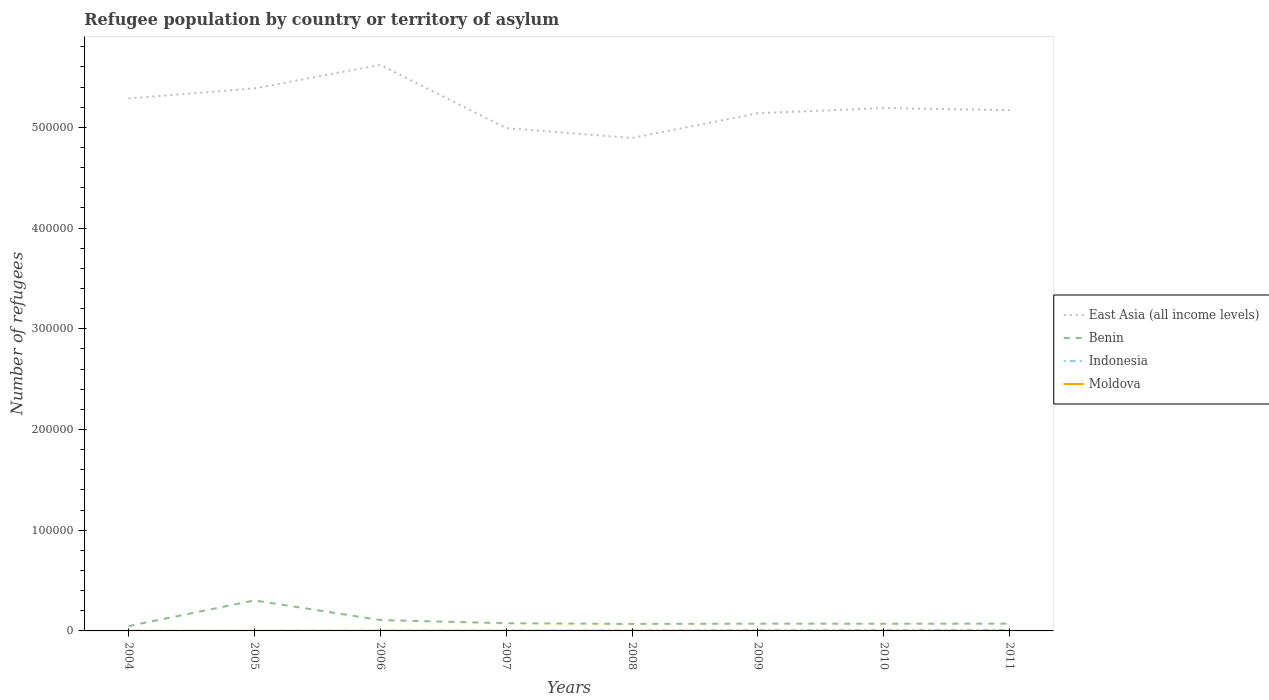Does the line corresponding to Indonesia intersect with the line corresponding to East Asia (all income levels)?
Your answer should be compact. No. Across all years, what is the maximum number of refugees in Benin?
Offer a terse response. 4802. What is the total number of refugees in Benin in the graph?
Ensure brevity in your answer.  -206. What is the difference between the highest and the second highest number of refugees in Moldova?
Give a very brief answer. 104. What is the difference between the highest and the lowest number of refugees in Moldova?
Your answer should be very brief. 6. Is the number of refugees in East Asia (all income levels) strictly greater than the number of refugees in Indonesia over the years?
Provide a short and direct response. No. How many lines are there?
Offer a terse response. 4. What is the difference between two consecutive major ticks on the Y-axis?
Offer a very short reply. 1.00e+05. Does the graph contain grids?
Offer a very short reply. No. Where does the legend appear in the graph?
Offer a terse response. Center right. How many legend labels are there?
Provide a succinct answer. 4. How are the legend labels stacked?
Keep it short and to the point. Vertical. What is the title of the graph?
Make the answer very short. Refugee population by country or territory of asylum. What is the label or title of the Y-axis?
Offer a terse response. Number of refugees. What is the Number of refugees of East Asia (all income levels) in 2004?
Your answer should be very brief. 5.29e+05. What is the Number of refugees of Benin in 2004?
Keep it short and to the point. 4802. What is the Number of refugees of Indonesia in 2004?
Offer a terse response. 169. What is the Number of refugees in Moldova in 2004?
Offer a terse response. 57. What is the Number of refugees of East Asia (all income levels) in 2005?
Your answer should be compact. 5.39e+05. What is the Number of refugees of Benin in 2005?
Ensure brevity in your answer.  3.03e+04. What is the Number of refugees of Indonesia in 2005?
Your answer should be compact. 89. What is the Number of refugees in East Asia (all income levels) in 2006?
Your answer should be compact. 5.62e+05. What is the Number of refugees of Benin in 2006?
Ensure brevity in your answer.  1.08e+04. What is the Number of refugees in Indonesia in 2006?
Your response must be concise. 301. What is the Number of refugees in Moldova in 2006?
Make the answer very short. 161. What is the Number of refugees in East Asia (all income levels) in 2007?
Your response must be concise. 4.99e+05. What is the Number of refugees in Benin in 2007?
Ensure brevity in your answer.  7621. What is the Number of refugees of Indonesia in 2007?
Keep it short and to the point. 315. What is the Number of refugees of Moldova in 2007?
Give a very brief answer. 151. What is the Number of refugees in East Asia (all income levels) in 2008?
Ensure brevity in your answer.  4.90e+05. What is the Number of refugees of Benin in 2008?
Provide a succinct answer. 6933. What is the Number of refugees of Indonesia in 2008?
Offer a very short reply. 369. What is the Number of refugees in Moldova in 2008?
Provide a short and direct response. 148. What is the Number of refugees in East Asia (all income levels) in 2009?
Provide a short and direct response. 5.14e+05. What is the Number of refugees in Benin in 2009?
Make the answer very short. 7205. What is the Number of refugees in Indonesia in 2009?
Your answer should be very brief. 798. What is the Number of refugees of Moldova in 2009?
Keep it short and to the point. 141. What is the Number of refugees in East Asia (all income levels) in 2010?
Offer a very short reply. 5.19e+05. What is the Number of refugees in Benin in 2010?
Provide a short and direct response. 7139. What is the Number of refugees of Indonesia in 2010?
Ensure brevity in your answer.  811. What is the Number of refugees of Moldova in 2010?
Your answer should be very brief. 148. What is the Number of refugees in East Asia (all income levels) in 2011?
Your answer should be compact. 5.17e+05. What is the Number of refugees of Benin in 2011?
Offer a very short reply. 7217. What is the Number of refugees of Indonesia in 2011?
Make the answer very short. 1006. What is the Number of refugees in Moldova in 2011?
Your answer should be very brief. 146. Across all years, what is the maximum Number of refugees in East Asia (all income levels)?
Your answer should be compact. 5.62e+05. Across all years, what is the maximum Number of refugees of Benin?
Your response must be concise. 3.03e+04. Across all years, what is the maximum Number of refugees in Indonesia?
Offer a terse response. 1006. Across all years, what is the maximum Number of refugees of Moldova?
Your answer should be very brief. 161. Across all years, what is the minimum Number of refugees of East Asia (all income levels)?
Offer a very short reply. 4.90e+05. Across all years, what is the minimum Number of refugees of Benin?
Make the answer very short. 4802. Across all years, what is the minimum Number of refugees of Indonesia?
Keep it short and to the point. 89. Across all years, what is the minimum Number of refugees in Moldova?
Your response must be concise. 57. What is the total Number of refugees in East Asia (all income levels) in the graph?
Your response must be concise. 4.17e+06. What is the total Number of refugees in Benin in the graph?
Give a very brief answer. 8.20e+04. What is the total Number of refugees of Indonesia in the graph?
Your answer should be very brief. 3858. What is the total Number of refugees in Moldova in the graph?
Make the answer very short. 1036. What is the difference between the Number of refugees of East Asia (all income levels) in 2004 and that in 2005?
Give a very brief answer. -9903. What is the difference between the Number of refugees in Benin in 2004 and that in 2005?
Ensure brevity in your answer.  -2.55e+04. What is the difference between the Number of refugees in Indonesia in 2004 and that in 2005?
Provide a succinct answer. 80. What is the difference between the Number of refugees of Moldova in 2004 and that in 2005?
Offer a terse response. -27. What is the difference between the Number of refugees of East Asia (all income levels) in 2004 and that in 2006?
Make the answer very short. -3.33e+04. What is the difference between the Number of refugees in Benin in 2004 and that in 2006?
Your response must be concise. -5995. What is the difference between the Number of refugees in Indonesia in 2004 and that in 2006?
Give a very brief answer. -132. What is the difference between the Number of refugees of Moldova in 2004 and that in 2006?
Offer a terse response. -104. What is the difference between the Number of refugees of East Asia (all income levels) in 2004 and that in 2007?
Keep it short and to the point. 2.95e+04. What is the difference between the Number of refugees of Benin in 2004 and that in 2007?
Give a very brief answer. -2819. What is the difference between the Number of refugees in Indonesia in 2004 and that in 2007?
Give a very brief answer. -146. What is the difference between the Number of refugees in Moldova in 2004 and that in 2007?
Your answer should be very brief. -94. What is the difference between the Number of refugees of East Asia (all income levels) in 2004 and that in 2008?
Offer a terse response. 3.92e+04. What is the difference between the Number of refugees of Benin in 2004 and that in 2008?
Your answer should be very brief. -2131. What is the difference between the Number of refugees of Indonesia in 2004 and that in 2008?
Ensure brevity in your answer.  -200. What is the difference between the Number of refugees in Moldova in 2004 and that in 2008?
Offer a very short reply. -91. What is the difference between the Number of refugees of East Asia (all income levels) in 2004 and that in 2009?
Keep it short and to the point. 1.47e+04. What is the difference between the Number of refugees in Benin in 2004 and that in 2009?
Your answer should be compact. -2403. What is the difference between the Number of refugees in Indonesia in 2004 and that in 2009?
Provide a succinct answer. -629. What is the difference between the Number of refugees in Moldova in 2004 and that in 2009?
Provide a succinct answer. -84. What is the difference between the Number of refugees in East Asia (all income levels) in 2004 and that in 2010?
Your answer should be very brief. 9552. What is the difference between the Number of refugees in Benin in 2004 and that in 2010?
Your response must be concise. -2337. What is the difference between the Number of refugees of Indonesia in 2004 and that in 2010?
Offer a very short reply. -642. What is the difference between the Number of refugees in Moldova in 2004 and that in 2010?
Provide a succinct answer. -91. What is the difference between the Number of refugees of East Asia (all income levels) in 2004 and that in 2011?
Provide a succinct answer. 1.17e+04. What is the difference between the Number of refugees of Benin in 2004 and that in 2011?
Give a very brief answer. -2415. What is the difference between the Number of refugees in Indonesia in 2004 and that in 2011?
Ensure brevity in your answer.  -837. What is the difference between the Number of refugees of Moldova in 2004 and that in 2011?
Provide a succinct answer. -89. What is the difference between the Number of refugees in East Asia (all income levels) in 2005 and that in 2006?
Provide a short and direct response. -2.34e+04. What is the difference between the Number of refugees in Benin in 2005 and that in 2006?
Your answer should be very brief. 1.95e+04. What is the difference between the Number of refugees of Indonesia in 2005 and that in 2006?
Ensure brevity in your answer.  -212. What is the difference between the Number of refugees of Moldova in 2005 and that in 2006?
Provide a succinct answer. -77. What is the difference between the Number of refugees in East Asia (all income levels) in 2005 and that in 2007?
Your answer should be compact. 3.94e+04. What is the difference between the Number of refugees in Benin in 2005 and that in 2007?
Keep it short and to the point. 2.27e+04. What is the difference between the Number of refugees of Indonesia in 2005 and that in 2007?
Your response must be concise. -226. What is the difference between the Number of refugees in Moldova in 2005 and that in 2007?
Keep it short and to the point. -67. What is the difference between the Number of refugees in East Asia (all income levels) in 2005 and that in 2008?
Your answer should be very brief. 4.92e+04. What is the difference between the Number of refugees of Benin in 2005 and that in 2008?
Your response must be concise. 2.34e+04. What is the difference between the Number of refugees in Indonesia in 2005 and that in 2008?
Your response must be concise. -280. What is the difference between the Number of refugees in Moldova in 2005 and that in 2008?
Make the answer very short. -64. What is the difference between the Number of refugees of East Asia (all income levels) in 2005 and that in 2009?
Your answer should be very brief. 2.46e+04. What is the difference between the Number of refugees of Benin in 2005 and that in 2009?
Your response must be concise. 2.31e+04. What is the difference between the Number of refugees of Indonesia in 2005 and that in 2009?
Provide a short and direct response. -709. What is the difference between the Number of refugees in Moldova in 2005 and that in 2009?
Ensure brevity in your answer.  -57. What is the difference between the Number of refugees in East Asia (all income levels) in 2005 and that in 2010?
Offer a very short reply. 1.95e+04. What is the difference between the Number of refugees of Benin in 2005 and that in 2010?
Ensure brevity in your answer.  2.32e+04. What is the difference between the Number of refugees in Indonesia in 2005 and that in 2010?
Ensure brevity in your answer.  -722. What is the difference between the Number of refugees in Moldova in 2005 and that in 2010?
Offer a terse response. -64. What is the difference between the Number of refugees in East Asia (all income levels) in 2005 and that in 2011?
Make the answer very short. 2.16e+04. What is the difference between the Number of refugees in Benin in 2005 and that in 2011?
Give a very brief answer. 2.31e+04. What is the difference between the Number of refugees of Indonesia in 2005 and that in 2011?
Ensure brevity in your answer.  -917. What is the difference between the Number of refugees of Moldova in 2005 and that in 2011?
Ensure brevity in your answer.  -62. What is the difference between the Number of refugees of East Asia (all income levels) in 2006 and that in 2007?
Provide a short and direct response. 6.28e+04. What is the difference between the Number of refugees in Benin in 2006 and that in 2007?
Make the answer very short. 3176. What is the difference between the Number of refugees in Indonesia in 2006 and that in 2007?
Provide a short and direct response. -14. What is the difference between the Number of refugees in East Asia (all income levels) in 2006 and that in 2008?
Make the answer very short. 7.26e+04. What is the difference between the Number of refugees of Benin in 2006 and that in 2008?
Make the answer very short. 3864. What is the difference between the Number of refugees in Indonesia in 2006 and that in 2008?
Ensure brevity in your answer.  -68. What is the difference between the Number of refugees in Moldova in 2006 and that in 2008?
Your answer should be compact. 13. What is the difference between the Number of refugees of East Asia (all income levels) in 2006 and that in 2009?
Offer a terse response. 4.80e+04. What is the difference between the Number of refugees in Benin in 2006 and that in 2009?
Offer a terse response. 3592. What is the difference between the Number of refugees of Indonesia in 2006 and that in 2009?
Your response must be concise. -497. What is the difference between the Number of refugees of East Asia (all income levels) in 2006 and that in 2010?
Offer a terse response. 4.29e+04. What is the difference between the Number of refugees of Benin in 2006 and that in 2010?
Ensure brevity in your answer.  3658. What is the difference between the Number of refugees of Indonesia in 2006 and that in 2010?
Your response must be concise. -510. What is the difference between the Number of refugees of East Asia (all income levels) in 2006 and that in 2011?
Your response must be concise. 4.50e+04. What is the difference between the Number of refugees of Benin in 2006 and that in 2011?
Your answer should be compact. 3580. What is the difference between the Number of refugees of Indonesia in 2006 and that in 2011?
Give a very brief answer. -705. What is the difference between the Number of refugees in Moldova in 2006 and that in 2011?
Keep it short and to the point. 15. What is the difference between the Number of refugees of East Asia (all income levels) in 2007 and that in 2008?
Ensure brevity in your answer.  9746. What is the difference between the Number of refugees of Benin in 2007 and that in 2008?
Your answer should be very brief. 688. What is the difference between the Number of refugees in Indonesia in 2007 and that in 2008?
Ensure brevity in your answer.  -54. What is the difference between the Number of refugees of East Asia (all income levels) in 2007 and that in 2009?
Offer a terse response. -1.48e+04. What is the difference between the Number of refugees in Benin in 2007 and that in 2009?
Your answer should be compact. 416. What is the difference between the Number of refugees of Indonesia in 2007 and that in 2009?
Your answer should be very brief. -483. What is the difference between the Number of refugees of Moldova in 2007 and that in 2009?
Provide a succinct answer. 10. What is the difference between the Number of refugees of East Asia (all income levels) in 2007 and that in 2010?
Make the answer very short. -2.00e+04. What is the difference between the Number of refugees in Benin in 2007 and that in 2010?
Give a very brief answer. 482. What is the difference between the Number of refugees of Indonesia in 2007 and that in 2010?
Give a very brief answer. -496. What is the difference between the Number of refugees of Moldova in 2007 and that in 2010?
Your answer should be very brief. 3. What is the difference between the Number of refugees of East Asia (all income levels) in 2007 and that in 2011?
Your answer should be very brief. -1.78e+04. What is the difference between the Number of refugees in Benin in 2007 and that in 2011?
Your answer should be compact. 404. What is the difference between the Number of refugees of Indonesia in 2007 and that in 2011?
Ensure brevity in your answer.  -691. What is the difference between the Number of refugees in Moldova in 2007 and that in 2011?
Keep it short and to the point. 5. What is the difference between the Number of refugees of East Asia (all income levels) in 2008 and that in 2009?
Give a very brief answer. -2.46e+04. What is the difference between the Number of refugees of Benin in 2008 and that in 2009?
Offer a terse response. -272. What is the difference between the Number of refugees of Indonesia in 2008 and that in 2009?
Make the answer very short. -429. What is the difference between the Number of refugees of East Asia (all income levels) in 2008 and that in 2010?
Make the answer very short. -2.97e+04. What is the difference between the Number of refugees in Benin in 2008 and that in 2010?
Ensure brevity in your answer.  -206. What is the difference between the Number of refugees of Indonesia in 2008 and that in 2010?
Provide a short and direct response. -442. What is the difference between the Number of refugees of East Asia (all income levels) in 2008 and that in 2011?
Provide a succinct answer. -2.76e+04. What is the difference between the Number of refugees in Benin in 2008 and that in 2011?
Provide a short and direct response. -284. What is the difference between the Number of refugees in Indonesia in 2008 and that in 2011?
Ensure brevity in your answer.  -637. What is the difference between the Number of refugees in East Asia (all income levels) in 2009 and that in 2010?
Your answer should be very brief. -5144. What is the difference between the Number of refugees of East Asia (all income levels) in 2009 and that in 2011?
Make the answer very short. -3021. What is the difference between the Number of refugees in Indonesia in 2009 and that in 2011?
Your response must be concise. -208. What is the difference between the Number of refugees in Moldova in 2009 and that in 2011?
Offer a very short reply. -5. What is the difference between the Number of refugees of East Asia (all income levels) in 2010 and that in 2011?
Offer a very short reply. 2123. What is the difference between the Number of refugees in Benin in 2010 and that in 2011?
Your answer should be very brief. -78. What is the difference between the Number of refugees in Indonesia in 2010 and that in 2011?
Ensure brevity in your answer.  -195. What is the difference between the Number of refugees in East Asia (all income levels) in 2004 and the Number of refugees in Benin in 2005?
Your response must be concise. 4.98e+05. What is the difference between the Number of refugees of East Asia (all income levels) in 2004 and the Number of refugees of Indonesia in 2005?
Make the answer very short. 5.29e+05. What is the difference between the Number of refugees of East Asia (all income levels) in 2004 and the Number of refugees of Moldova in 2005?
Offer a terse response. 5.29e+05. What is the difference between the Number of refugees of Benin in 2004 and the Number of refugees of Indonesia in 2005?
Your answer should be very brief. 4713. What is the difference between the Number of refugees in Benin in 2004 and the Number of refugees in Moldova in 2005?
Make the answer very short. 4718. What is the difference between the Number of refugees in Indonesia in 2004 and the Number of refugees in Moldova in 2005?
Keep it short and to the point. 85. What is the difference between the Number of refugees of East Asia (all income levels) in 2004 and the Number of refugees of Benin in 2006?
Ensure brevity in your answer.  5.18e+05. What is the difference between the Number of refugees of East Asia (all income levels) in 2004 and the Number of refugees of Indonesia in 2006?
Your response must be concise. 5.28e+05. What is the difference between the Number of refugees of East Asia (all income levels) in 2004 and the Number of refugees of Moldova in 2006?
Keep it short and to the point. 5.29e+05. What is the difference between the Number of refugees of Benin in 2004 and the Number of refugees of Indonesia in 2006?
Your answer should be compact. 4501. What is the difference between the Number of refugees in Benin in 2004 and the Number of refugees in Moldova in 2006?
Provide a succinct answer. 4641. What is the difference between the Number of refugees in East Asia (all income levels) in 2004 and the Number of refugees in Benin in 2007?
Give a very brief answer. 5.21e+05. What is the difference between the Number of refugees in East Asia (all income levels) in 2004 and the Number of refugees in Indonesia in 2007?
Ensure brevity in your answer.  5.28e+05. What is the difference between the Number of refugees in East Asia (all income levels) in 2004 and the Number of refugees in Moldova in 2007?
Your response must be concise. 5.29e+05. What is the difference between the Number of refugees in Benin in 2004 and the Number of refugees in Indonesia in 2007?
Provide a short and direct response. 4487. What is the difference between the Number of refugees in Benin in 2004 and the Number of refugees in Moldova in 2007?
Ensure brevity in your answer.  4651. What is the difference between the Number of refugees in East Asia (all income levels) in 2004 and the Number of refugees in Benin in 2008?
Give a very brief answer. 5.22e+05. What is the difference between the Number of refugees of East Asia (all income levels) in 2004 and the Number of refugees of Indonesia in 2008?
Provide a succinct answer. 5.28e+05. What is the difference between the Number of refugees of East Asia (all income levels) in 2004 and the Number of refugees of Moldova in 2008?
Offer a terse response. 5.29e+05. What is the difference between the Number of refugees of Benin in 2004 and the Number of refugees of Indonesia in 2008?
Your answer should be compact. 4433. What is the difference between the Number of refugees of Benin in 2004 and the Number of refugees of Moldova in 2008?
Provide a short and direct response. 4654. What is the difference between the Number of refugees in Indonesia in 2004 and the Number of refugees in Moldova in 2008?
Offer a terse response. 21. What is the difference between the Number of refugees in East Asia (all income levels) in 2004 and the Number of refugees in Benin in 2009?
Your answer should be very brief. 5.22e+05. What is the difference between the Number of refugees of East Asia (all income levels) in 2004 and the Number of refugees of Indonesia in 2009?
Offer a terse response. 5.28e+05. What is the difference between the Number of refugees in East Asia (all income levels) in 2004 and the Number of refugees in Moldova in 2009?
Keep it short and to the point. 5.29e+05. What is the difference between the Number of refugees in Benin in 2004 and the Number of refugees in Indonesia in 2009?
Your answer should be compact. 4004. What is the difference between the Number of refugees of Benin in 2004 and the Number of refugees of Moldova in 2009?
Provide a succinct answer. 4661. What is the difference between the Number of refugees of East Asia (all income levels) in 2004 and the Number of refugees of Benin in 2010?
Offer a very short reply. 5.22e+05. What is the difference between the Number of refugees in East Asia (all income levels) in 2004 and the Number of refugees in Indonesia in 2010?
Give a very brief answer. 5.28e+05. What is the difference between the Number of refugees of East Asia (all income levels) in 2004 and the Number of refugees of Moldova in 2010?
Give a very brief answer. 5.29e+05. What is the difference between the Number of refugees in Benin in 2004 and the Number of refugees in Indonesia in 2010?
Offer a very short reply. 3991. What is the difference between the Number of refugees of Benin in 2004 and the Number of refugees of Moldova in 2010?
Offer a very short reply. 4654. What is the difference between the Number of refugees of Indonesia in 2004 and the Number of refugees of Moldova in 2010?
Make the answer very short. 21. What is the difference between the Number of refugees in East Asia (all income levels) in 2004 and the Number of refugees in Benin in 2011?
Your answer should be very brief. 5.22e+05. What is the difference between the Number of refugees in East Asia (all income levels) in 2004 and the Number of refugees in Indonesia in 2011?
Provide a succinct answer. 5.28e+05. What is the difference between the Number of refugees in East Asia (all income levels) in 2004 and the Number of refugees in Moldova in 2011?
Keep it short and to the point. 5.29e+05. What is the difference between the Number of refugees in Benin in 2004 and the Number of refugees in Indonesia in 2011?
Your answer should be compact. 3796. What is the difference between the Number of refugees in Benin in 2004 and the Number of refugees in Moldova in 2011?
Keep it short and to the point. 4656. What is the difference between the Number of refugees in East Asia (all income levels) in 2005 and the Number of refugees in Benin in 2006?
Provide a short and direct response. 5.28e+05. What is the difference between the Number of refugees of East Asia (all income levels) in 2005 and the Number of refugees of Indonesia in 2006?
Keep it short and to the point. 5.38e+05. What is the difference between the Number of refugees of East Asia (all income levels) in 2005 and the Number of refugees of Moldova in 2006?
Provide a succinct answer. 5.39e+05. What is the difference between the Number of refugees in Benin in 2005 and the Number of refugees in Indonesia in 2006?
Offer a terse response. 3.00e+04. What is the difference between the Number of refugees of Benin in 2005 and the Number of refugees of Moldova in 2006?
Keep it short and to the point. 3.01e+04. What is the difference between the Number of refugees of Indonesia in 2005 and the Number of refugees of Moldova in 2006?
Offer a very short reply. -72. What is the difference between the Number of refugees of East Asia (all income levels) in 2005 and the Number of refugees of Benin in 2007?
Offer a very short reply. 5.31e+05. What is the difference between the Number of refugees of East Asia (all income levels) in 2005 and the Number of refugees of Indonesia in 2007?
Offer a very short reply. 5.38e+05. What is the difference between the Number of refugees of East Asia (all income levels) in 2005 and the Number of refugees of Moldova in 2007?
Ensure brevity in your answer.  5.39e+05. What is the difference between the Number of refugees in Benin in 2005 and the Number of refugees in Indonesia in 2007?
Your response must be concise. 3.00e+04. What is the difference between the Number of refugees of Benin in 2005 and the Number of refugees of Moldova in 2007?
Provide a short and direct response. 3.01e+04. What is the difference between the Number of refugees of Indonesia in 2005 and the Number of refugees of Moldova in 2007?
Provide a succinct answer. -62. What is the difference between the Number of refugees in East Asia (all income levels) in 2005 and the Number of refugees in Benin in 2008?
Provide a short and direct response. 5.32e+05. What is the difference between the Number of refugees in East Asia (all income levels) in 2005 and the Number of refugees in Indonesia in 2008?
Provide a succinct answer. 5.38e+05. What is the difference between the Number of refugees in East Asia (all income levels) in 2005 and the Number of refugees in Moldova in 2008?
Your answer should be very brief. 5.39e+05. What is the difference between the Number of refugees in Benin in 2005 and the Number of refugees in Indonesia in 2008?
Your answer should be very brief. 2.99e+04. What is the difference between the Number of refugees of Benin in 2005 and the Number of refugees of Moldova in 2008?
Your response must be concise. 3.01e+04. What is the difference between the Number of refugees of Indonesia in 2005 and the Number of refugees of Moldova in 2008?
Offer a terse response. -59. What is the difference between the Number of refugees in East Asia (all income levels) in 2005 and the Number of refugees in Benin in 2009?
Give a very brief answer. 5.31e+05. What is the difference between the Number of refugees of East Asia (all income levels) in 2005 and the Number of refugees of Indonesia in 2009?
Provide a short and direct response. 5.38e+05. What is the difference between the Number of refugees in East Asia (all income levels) in 2005 and the Number of refugees in Moldova in 2009?
Your answer should be compact. 5.39e+05. What is the difference between the Number of refugees in Benin in 2005 and the Number of refugees in Indonesia in 2009?
Your answer should be very brief. 2.95e+04. What is the difference between the Number of refugees in Benin in 2005 and the Number of refugees in Moldova in 2009?
Make the answer very short. 3.02e+04. What is the difference between the Number of refugees in Indonesia in 2005 and the Number of refugees in Moldova in 2009?
Keep it short and to the point. -52. What is the difference between the Number of refugees of East Asia (all income levels) in 2005 and the Number of refugees of Benin in 2010?
Keep it short and to the point. 5.32e+05. What is the difference between the Number of refugees of East Asia (all income levels) in 2005 and the Number of refugees of Indonesia in 2010?
Offer a very short reply. 5.38e+05. What is the difference between the Number of refugees in East Asia (all income levels) in 2005 and the Number of refugees in Moldova in 2010?
Your answer should be very brief. 5.39e+05. What is the difference between the Number of refugees in Benin in 2005 and the Number of refugees in Indonesia in 2010?
Keep it short and to the point. 2.95e+04. What is the difference between the Number of refugees in Benin in 2005 and the Number of refugees in Moldova in 2010?
Your response must be concise. 3.01e+04. What is the difference between the Number of refugees of Indonesia in 2005 and the Number of refugees of Moldova in 2010?
Keep it short and to the point. -59. What is the difference between the Number of refugees of East Asia (all income levels) in 2005 and the Number of refugees of Benin in 2011?
Provide a short and direct response. 5.31e+05. What is the difference between the Number of refugees in East Asia (all income levels) in 2005 and the Number of refugees in Indonesia in 2011?
Provide a succinct answer. 5.38e+05. What is the difference between the Number of refugees in East Asia (all income levels) in 2005 and the Number of refugees in Moldova in 2011?
Your response must be concise. 5.39e+05. What is the difference between the Number of refugees in Benin in 2005 and the Number of refugees in Indonesia in 2011?
Provide a short and direct response. 2.93e+04. What is the difference between the Number of refugees of Benin in 2005 and the Number of refugees of Moldova in 2011?
Your response must be concise. 3.01e+04. What is the difference between the Number of refugees in Indonesia in 2005 and the Number of refugees in Moldova in 2011?
Offer a terse response. -57. What is the difference between the Number of refugees in East Asia (all income levels) in 2006 and the Number of refugees in Benin in 2007?
Your answer should be compact. 5.54e+05. What is the difference between the Number of refugees of East Asia (all income levels) in 2006 and the Number of refugees of Indonesia in 2007?
Make the answer very short. 5.62e+05. What is the difference between the Number of refugees of East Asia (all income levels) in 2006 and the Number of refugees of Moldova in 2007?
Ensure brevity in your answer.  5.62e+05. What is the difference between the Number of refugees in Benin in 2006 and the Number of refugees in Indonesia in 2007?
Provide a succinct answer. 1.05e+04. What is the difference between the Number of refugees of Benin in 2006 and the Number of refugees of Moldova in 2007?
Keep it short and to the point. 1.06e+04. What is the difference between the Number of refugees in Indonesia in 2006 and the Number of refugees in Moldova in 2007?
Make the answer very short. 150. What is the difference between the Number of refugees of East Asia (all income levels) in 2006 and the Number of refugees of Benin in 2008?
Provide a short and direct response. 5.55e+05. What is the difference between the Number of refugees in East Asia (all income levels) in 2006 and the Number of refugees in Indonesia in 2008?
Provide a short and direct response. 5.62e+05. What is the difference between the Number of refugees of East Asia (all income levels) in 2006 and the Number of refugees of Moldova in 2008?
Keep it short and to the point. 5.62e+05. What is the difference between the Number of refugees of Benin in 2006 and the Number of refugees of Indonesia in 2008?
Make the answer very short. 1.04e+04. What is the difference between the Number of refugees of Benin in 2006 and the Number of refugees of Moldova in 2008?
Keep it short and to the point. 1.06e+04. What is the difference between the Number of refugees of Indonesia in 2006 and the Number of refugees of Moldova in 2008?
Your answer should be very brief. 153. What is the difference between the Number of refugees in East Asia (all income levels) in 2006 and the Number of refugees in Benin in 2009?
Your response must be concise. 5.55e+05. What is the difference between the Number of refugees in East Asia (all income levels) in 2006 and the Number of refugees in Indonesia in 2009?
Offer a terse response. 5.61e+05. What is the difference between the Number of refugees in East Asia (all income levels) in 2006 and the Number of refugees in Moldova in 2009?
Keep it short and to the point. 5.62e+05. What is the difference between the Number of refugees in Benin in 2006 and the Number of refugees in Indonesia in 2009?
Your answer should be compact. 9999. What is the difference between the Number of refugees in Benin in 2006 and the Number of refugees in Moldova in 2009?
Give a very brief answer. 1.07e+04. What is the difference between the Number of refugees in Indonesia in 2006 and the Number of refugees in Moldova in 2009?
Provide a succinct answer. 160. What is the difference between the Number of refugees in East Asia (all income levels) in 2006 and the Number of refugees in Benin in 2010?
Give a very brief answer. 5.55e+05. What is the difference between the Number of refugees in East Asia (all income levels) in 2006 and the Number of refugees in Indonesia in 2010?
Provide a short and direct response. 5.61e+05. What is the difference between the Number of refugees of East Asia (all income levels) in 2006 and the Number of refugees of Moldova in 2010?
Your answer should be very brief. 5.62e+05. What is the difference between the Number of refugees in Benin in 2006 and the Number of refugees in Indonesia in 2010?
Make the answer very short. 9986. What is the difference between the Number of refugees in Benin in 2006 and the Number of refugees in Moldova in 2010?
Provide a succinct answer. 1.06e+04. What is the difference between the Number of refugees in Indonesia in 2006 and the Number of refugees in Moldova in 2010?
Keep it short and to the point. 153. What is the difference between the Number of refugees of East Asia (all income levels) in 2006 and the Number of refugees of Benin in 2011?
Give a very brief answer. 5.55e+05. What is the difference between the Number of refugees of East Asia (all income levels) in 2006 and the Number of refugees of Indonesia in 2011?
Offer a terse response. 5.61e+05. What is the difference between the Number of refugees in East Asia (all income levels) in 2006 and the Number of refugees in Moldova in 2011?
Keep it short and to the point. 5.62e+05. What is the difference between the Number of refugees of Benin in 2006 and the Number of refugees of Indonesia in 2011?
Offer a very short reply. 9791. What is the difference between the Number of refugees in Benin in 2006 and the Number of refugees in Moldova in 2011?
Provide a short and direct response. 1.07e+04. What is the difference between the Number of refugees of Indonesia in 2006 and the Number of refugees of Moldova in 2011?
Keep it short and to the point. 155. What is the difference between the Number of refugees in East Asia (all income levels) in 2007 and the Number of refugees in Benin in 2008?
Make the answer very short. 4.92e+05. What is the difference between the Number of refugees in East Asia (all income levels) in 2007 and the Number of refugees in Indonesia in 2008?
Ensure brevity in your answer.  4.99e+05. What is the difference between the Number of refugees of East Asia (all income levels) in 2007 and the Number of refugees of Moldova in 2008?
Your answer should be compact. 4.99e+05. What is the difference between the Number of refugees of Benin in 2007 and the Number of refugees of Indonesia in 2008?
Give a very brief answer. 7252. What is the difference between the Number of refugees in Benin in 2007 and the Number of refugees in Moldova in 2008?
Your answer should be compact. 7473. What is the difference between the Number of refugees in Indonesia in 2007 and the Number of refugees in Moldova in 2008?
Keep it short and to the point. 167. What is the difference between the Number of refugees of East Asia (all income levels) in 2007 and the Number of refugees of Benin in 2009?
Offer a terse response. 4.92e+05. What is the difference between the Number of refugees in East Asia (all income levels) in 2007 and the Number of refugees in Indonesia in 2009?
Keep it short and to the point. 4.98e+05. What is the difference between the Number of refugees of East Asia (all income levels) in 2007 and the Number of refugees of Moldova in 2009?
Make the answer very short. 4.99e+05. What is the difference between the Number of refugees in Benin in 2007 and the Number of refugees in Indonesia in 2009?
Your answer should be very brief. 6823. What is the difference between the Number of refugees of Benin in 2007 and the Number of refugees of Moldova in 2009?
Your response must be concise. 7480. What is the difference between the Number of refugees in Indonesia in 2007 and the Number of refugees in Moldova in 2009?
Provide a succinct answer. 174. What is the difference between the Number of refugees in East Asia (all income levels) in 2007 and the Number of refugees in Benin in 2010?
Your answer should be very brief. 4.92e+05. What is the difference between the Number of refugees in East Asia (all income levels) in 2007 and the Number of refugees in Indonesia in 2010?
Offer a very short reply. 4.98e+05. What is the difference between the Number of refugees of East Asia (all income levels) in 2007 and the Number of refugees of Moldova in 2010?
Ensure brevity in your answer.  4.99e+05. What is the difference between the Number of refugees in Benin in 2007 and the Number of refugees in Indonesia in 2010?
Keep it short and to the point. 6810. What is the difference between the Number of refugees of Benin in 2007 and the Number of refugees of Moldova in 2010?
Keep it short and to the point. 7473. What is the difference between the Number of refugees of Indonesia in 2007 and the Number of refugees of Moldova in 2010?
Your answer should be compact. 167. What is the difference between the Number of refugees in East Asia (all income levels) in 2007 and the Number of refugees in Benin in 2011?
Offer a very short reply. 4.92e+05. What is the difference between the Number of refugees of East Asia (all income levels) in 2007 and the Number of refugees of Indonesia in 2011?
Ensure brevity in your answer.  4.98e+05. What is the difference between the Number of refugees in East Asia (all income levels) in 2007 and the Number of refugees in Moldova in 2011?
Provide a short and direct response. 4.99e+05. What is the difference between the Number of refugees of Benin in 2007 and the Number of refugees of Indonesia in 2011?
Ensure brevity in your answer.  6615. What is the difference between the Number of refugees of Benin in 2007 and the Number of refugees of Moldova in 2011?
Ensure brevity in your answer.  7475. What is the difference between the Number of refugees in Indonesia in 2007 and the Number of refugees in Moldova in 2011?
Offer a very short reply. 169. What is the difference between the Number of refugees in East Asia (all income levels) in 2008 and the Number of refugees in Benin in 2009?
Keep it short and to the point. 4.82e+05. What is the difference between the Number of refugees of East Asia (all income levels) in 2008 and the Number of refugees of Indonesia in 2009?
Keep it short and to the point. 4.89e+05. What is the difference between the Number of refugees in East Asia (all income levels) in 2008 and the Number of refugees in Moldova in 2009?
Your response must be concise. 4.89e+05. What is the difference between the Number of refugees in Benin in 2008 and the Number of refugees in Indonesia in 2009?
Offer a very short reply. 6135. What is the difference between the Number of refugees in Benin in 2008 and the Number of refugees in Moldova in 2009?
Your response must be concise. 6792. What is the difference between the Number of refugees in Indonesia in 2008 and the Number of refugees in Moldova in 2009?
Provide a succinct answer. 228. What is the difference between the Number of refugees of East Asia (all income levels) in 2008 and the Number of refugees of Benin in 2010?
Provide a short and direct response. 4.82e+05. What is the difference between the Number of refugees of East Asia (all income levels) in 2008 and the Number of refugees of Indonesia in 2010?
Give a very brief answer. 4.89e+05. What is the difference between the Number of refugees of East Asia (all income levels) in 2008 and the Number of refugees of Moldova in 2010?
Your answer should be very brief. 4.89e+05. What is the difference between the Number of refugees in Benin in 2008 and the Number of refugees in Indonesia in 2010?
Offer a terse response. 6122. What is the difference between the Number of refugees in Benin in 2008 and the Number of refugees in Moldova in 2010?
Your answer should be very brief. 6785. What is the difference between the Number of refugees in Indonesia in 2008 and the Number of refugees in Moldova in 2010?
Your answer should be very brief. 221. What is the difference between the Number of refugees of East Asia (all income levels) in 2008 and the Number of refugees of Benin in 2011?
Your answer should be compact. 4.82e+05. What is the difference between the Number of refugees in East Asia (all income levels) in 2008 and the Number of refugees in Indonesia in 2011?
Provide a succinct answer. 4.89e+05. What is the difference between the Number of refugees of East Asia (all income levels) in 2008 and the Number of refugees of Moldova in 2011?
Your answer should be compact. 4.89e+05. What is the difference between the Number of refugees of Benin in 2008 and the Number of refugees of Indonesia in 2011?
Offer a terse response. 5927. What is the difference between the Number of refugees in Benin in 2008 and the Number of refugees in Moldova in 2011?
Offer a very short reply. 6787. What is the difference between the Number of refugees of Indonesia in 2008 and the Number of refugees of Moldova in 2011?
Your answer should be compact. 223. What is the difference between the Number of refugees of East Asia (all income levels) in 2009 and the Number of refugees of Benin in 2010?
Your answer should be very brief. 5.07e+05. What is the difference between the Number of refugees of East Asia (all income levels) in 2009 and the Number of refugees of Indonesia in 2010?
Your answer should be compact. 5.13e+05. What is the difference between the Number of refugees in East Asia (all income levels) in 2009 and the Number of refugees in Moldova in 2010?
Give a very brief answer. 5.14e+05. What is the difference between the Number of refugees in Benin in 2009 and the Number of refugees in Indonesia in 2010?
Offer a terse response. 6394. What is the difference between the Number of refugees of Benin in 2009 and the Number of refugees of Moldova in 2010?
Offer a very short reply. 7057. What is the difference between the Number of refugees in Indonesia in 2009 and the Number of refugees in Moldova in 2010?
Ensure brevity in your answer.  650. What is the difference between the Number of refugees in East Asia (all income levels) in 2009 and the Number of refugees in Benin in 2011?
Ensure brevity in your answer.  5.07e+05. What is the difference between the Number of refugees in East Asia (all income levels) in 2009 and the Number of refugees in Indonesia in 2011?
Give a very brief answer. 5.13e+05. What is the difference between the Number of refugees in East Asia (all income levels) in 2009 and the Number of refugees in Moldova in 2011?
Provide a short and direct response. 5.14e+05. What is the difference between the Number of refugees of Benin in 2009 and the Number of refugees of Indonesia in 2011?
Provide a succinct answer. 6199. What is the difference between the Number of refugees of Benin in 2009 and the Number of refugees of Moldova in 2011?
Ensure brevity in your answer.  7059. What is the difference between the Number of refugees of Indonesia in 2009 and the Number of refugees of Moldova in 2011?
Your answer should be compact. 652. What is the difference between the Number of refugees in East Asia (all income levels) in 2010 and the Number of refugees in Benin in 2011?
Keep it short and to the point. 5.12e+05. What is the difference between the Number of refugees of East Asia (all income levels) in 2010 and the Number of refugees of Indonesia in 2011?
Your answer should be compact. 5.18e+05. What is the difference between the Number of refugees in East Asia (all income levels) in 2010 and the Number of refugees in Moldova in 2011?
Your answer should be compact. 5.19e+05. What is the difference between the Number of refugees of Benin in 2010 and the Number of refugees of Indonesia in 2011?
Make the answer very short. 6133. What is the difference between the Number of refugees of Benin in 2010 and the Number of refugees of Moldova in 2011?
Your answer should be very brief. 6993. What is the difference between the Number of refugees of Indonesia in 2010 and the Number of refugees of Moldova in 2011?
Offer a terse response. 665. What is the average Number of refugees of East Asia (all income levels) per year?
Keep it short and to the point. 5.21e+05. What is the average Number of refugees of Benin per year?
Your answer should be compact. 1.03e+04. What is the average Number of refugees in Indonesia per year?
Ensure brevity in your answer.  482.25. What is the average Number of refugees in Moldova per year?
Provide a succinct answer. 129.5. In the year 2004, what is the difference between the Number of refugees of East Asia (all income levels) and Number of refugees of Benin?
Provide a short and direct response. 5.24e+05. In the year 2004, what is the difference between the Number of refugees of East Asia (all income levels) and Number of refugees of Indonesia?
Your answer should be very brief. 5.29e+05. In the year 2004, what is the difference between the Number of refugees in East Asia (all income levels) and Number of refugees in Moldova?
Make the answer very short. 5.29e+05. In the year 2004, what is the difference between the Number of refugees in Benin and Number of refugees in Indonesia?
Your answer should be very brief. 4633. In the year 2004, what is the difference between the Number of refugees of Benin and Number of refugees of Moldova?
Give a very brief answer. 4745. In the year 2004, what is the difference between the Number of refugees in Indonesia and Number of refugees in Moldova?
Your answer should be compact. 112. In the year 2005, what is the difference between the Number of refugees in East Asia (all income levels) and Number of refugees in Benin?
Your answer should be very brief. 5.08e+05. In the year 2005, what is the difference between the Number of refugees in East Asia (all income levels) and Number of refugees in Indonesia?
Offer a very short reply. 5.39e+05. In the year 2005, what is the difference between the Number of refugees in East Asia (all income levels) and Number of refugees in Moldova?
Your response must be concise. 5.39e+05. In the year 2005, what is the difference between the Number of refugees of Benin and Number of refugees of Indonesia?
Provide a short and direct response. 3.02e+04. In the year 2005, what is the difference between the Number of refugees of Benin and Number of refugees of Moldova?
Offer a very short reply. 3.02e+04. In the year 2006, what is the difference between the Number of refugees of East Asia (all income levels) and Number of refugees of Benin?
Your answer should be very brief. 5.51e+05. In the year 2006, what is the difference between the Number of refugees in East Asia (all income levels) and Number of refugees in Indonesia?
Keep it short and to the point. 5.62e+05. In the year 2006, what is the difference between the Number of refugees of East Asia (all income levels) and Number of refugees of Moldova?
Your answer should be compact. 5.62e+05. In the year 2006, what is the difference between the Number of refugees of Benin and Number of refugees of Indonesia?
Offer a very short reply. 1.05e+04. In the year 2006, what is the difference between the Number of refugees in Benin and Number of refugees in Moldova?
Your response must be concise. 1.06e+04. In the year 2006, what is the difference between the Number of refugees of Indonesia and Number of refugees of Moldova?
Offer a terse response. 140. In the year 2007, what is the difference between the Number of refugees of East Asia (all income levels) and Number of refugees of Benin?
Your response must be concise. 4.92e+05. In the year 2007, what is the difference between the Number of refugees in East Asia (all income levels) and Number of refugees in Indonesia?
Your answer should be compact. 4.99e+05. In the year 2007, what is the difference between the Number of refugees of East Asia (all income levels) and Number of refugees of Moldova?
Offer a terse response. 4.99e+05. In the year 2007, what is the difference between the Number of refugees in Benin and Number of refugees in Indonesia?
Provide a short and direct response. 7306. In the year 2007, what is the difference between the Number of refugees in Benin and Number of refugees in Moldova?
Your response must be concise. 7470. In the year 2007, what is the difference between the Number of refugees of Indonesia and Number of refugees of Moldova?
Provide a short and direct response. 164. In the year 2008, what is the difference between the Number of refugees in East Asia (all income levels) and Number of refugees in Benin?
Your response must be concise. 4.83e+05. In the year 2008, what is the difference between the Number of refugees in East Asia (all income levels) and Number of refugees in Indonesia?
Provide a short and direct response. 4.89e+05. In the year 2008, what is the difference between the Number of refugees of East Asia (all income levels) and Number of refugees of Moldova?
Give a very brief answer. 4.89e+05. In the year 2008, what is the difference between the Number of refugees of Benin and Number of refugees of Indonesia?
Your answer should be very brief. 6564. In the year 2008, what is the difference between the Number of refugees in Benin and Number of refugees in Moldova?
Make the answer very short. 6785. In the year 2008, what is the difference between the Number of refugees of Indonesia and Number of refugees of Moldova?
Provide a short and direct response. 221. In the year 2009, what is the difference between the Number of refugees in East Asia (all income levels) and Number of refugees in Benin?
Your answer should be very brief. 5.07e+05. In the year 2009, what is the difference between the Number of refugees in East Asia (all income levels) and Number of refugees in Indonesia?
Your answer should be compact. 5.13e+05. In the year 2009, what is the difference between the Number of refugees of East Asia (all income levels) and Number of refugees of Moldova?
Ensure brevity in your answer.  5.14e+05. In the year 2009, what is the difference between the Number of refugees of Benin and Number of refugees of Indonesia?
Your response must be concise. 6407. In the year 2009, what is the difference between the Number of refugees in Benin and Number of refugees in Moldova?
Give a very brief answer. 7064. In the year 2009, what is the difference between the Number of refugees of Indonesia and Number of refugees of Moldova?
Keep it short and to the point. 657. In the year 2010, what is the difference between the Number of refugees in East Asia (all income levels) and Number of refugees in Benin?
Offer a terse response. 5.12e+05. In the year 2010, what is the difference between the Number of refugees in East Asia (all income levels) and Number of refugees in Indonesia?
Your response must be concise. 5.18e+05. In the year 2010, what is the difference between the Number of refugees in East Asia (all income levels) and Number of refugees in Moldova?
Offer a very short reply. 5.19e+05. In the year 2010, what is the difference between the Number of refugees of Benin and Number of refugees of Indonesia?
Your response must be concise. 6328. In the year 2010, what is the difference between the Number of refugees of Benin and Number of refugees of Moldova?
Make the answer very short. 6991. In the year 2010, what is the difference between the Number of refugees in Indonesia and Number of refugees in Moldova?
Offer a very short reply. 663. In the year 2011, what is the difference between the Number of refugees of East Asia (all income levels) and Number of refugees of Benin?
Your response must be concise. 5.10e+05. In the year 2011, what is the difference between the Number of refugees in East Asia (all income levels) and Number of refugees in Indonesia?
Provide a succinct answer. 5.16e+05. In the year 2011, what is the difference between the Number of refugees of East Asia (all income levels) and Number of refugees of Moldova?
Keep it short and to the point. 5.17e+05. In the year 2011, what is the difference between the Number of refugees of Benin and Number of refugees of Indonesia?
Offer a very short reply. 6211. In the year 2011, what is the difference between the Number of refugees of Benin and Number of refugees of Moldova?
Offer a terse response. 7071. In the year 2011, what is the difference between the Number of refugees in Indonesia and Number of refugees in Moldova?
Offer a terse response. 860. What is the ratio of the Number of refugees in East Asia (all income levels) in 2004 to that in 2005?
Provide a short and direct response. 0.98. What is the ratio of the Number of refugees in Benin in 2004 to that in 2005?
Keep it short and to the point. 0.16. What is the ratio of the Number of refugees of Indonesia in 2004 to that in 2005?
Provide a short and direct response. 1.9. What is the ratio of the Number of refugees of Moldova in 2004 to that in 2005?
Offer a very short reply. 0.68. What is the ratio of the Number of refugees of East Asia (all income levels) in 2004 to that in 2006?
Provide a succinct answer. 0.94. What is the ratio of the Number of refugees of Benin in 2004 to that in 2006?
Make the answer very short. 0.44. What is the ratio of the Number of refugees of Indonesia in 2004 to that in 2006?
Provide a succinct answer. 0.56. What is the ratio of the Number of refugees in Moldova in 2004 to that in 2006?
Keep it short and to the point. 0.35. What is the ratio of the Number of refugees in East Asia (all income levels) in 2004 to that in 2007?
Your response must be concise. 1.06. What is the ratio of the Number of refugees of Benin in 2004 to that in 2007?
Provide a short and direct response. 0.63. What is the ratio of the Number of refugees in Indonesia in 2004 to that in 2007?
Your answer should be compact. 0.54. What is the ratio of the Number of refugees of Moldova in 2004 to that in 2007?
Your answer should be very brief. 0.38. What is the ratio of the Number of refugees of East Asia (all income levels) in 2004 to that in 2008?
Offer a very short reply. 1.08. What is the ratio of the Number of refugees in Benin in 2004 to that in 2008?
Ensure brevity in your answer.  0.69. What is the ratio of the Number of refugees in Indonesia in 2004 to that in 2008?
Your response must be concise. 0.46. What is the ratio of the Number of refugees of Moldova in 2004 to that in 2008?
Give a very brief answer. 0.39. What is the ratio of the Number of refugees of East Asia (all income levels) in 2004 to that in 2009?
Keep it short and to the point. 1.03. What is the ratio of the Number of refugees of Benin in 2004 to that in 2009?
Give a very brief answer. 0.67. What is the ratio of the Number of refugees of Indonesia in 2004 to that in 2009?
Give a very brief answer. 0.21. What is the ratio of the Number of refugees in Moldova in 2004 to that in 2009?
Your answer should be compact. 0.4. What is the ratio of the Number of refugees in East Asia (all income levels) in 2004 to that in 2010?
Provide a short and direct response. 1.02. What is the ratio of the Number of refugees in Benin in 2004 to that in 2010?
Offer a very short reply. 0.67. What is the ratio of the Number of refugees of Indonesia in 2004 to that in 2010?
Offer a very short reply. 0.21. What is the ratio of the Number of refugees of Moldova in 2004 to that in 2010?
Provide a succinct answer. 0.39. What is the ratio of the Number of refugees of East Asia (all income levels) in 2004 to that in 2011?
Make the answer very short. 1.02. What is the ratio of the Number of refugees of Benin in 2004 to that in 2011?
Give a very brief answer. 0.67. What is the ratio of the Number of refugees of Indonesia in 2004 to that in 2011?
Keep it short and to the point. 0.17. What is the ratio of the Number of refugees of Moldova in 2004 to that in 2011?
Ensure brevity in your answer.  0.39. What is the ratio of the Number of refugees of Benin in 2005 to that in 2006?
Keep it short and to the point. 2.81. What is the ratio of the Number of refugees of Indonesia in 2005 to that in 2006?
Ensure brevity in your answer.  0.3. What is the ratio of the Number of refugees in Moldova in 2005 to that in 2006?
Your response must be concise. 0.52. What is the ratio of the Number of refugees in East Asia (all income levels) in 2005 to that in 2007?
Offer a very short reply. 1.08. What is the ratio of the Number of refugees in Benin in 2005 to that in 2007?
Your response must be concise. 3.98. What is the ratio of the Number of refugees in Indonesia in 2005 to that in 2007?
Your answer should be compact. 0.28. What is the ratio of the Number of refugees of Moldova in 2005 to that in 2007?
Make the answer very short. 0.56. What is the ratio of the Number of refugees in East Asia (all income levels) in 2005 to that in 2008?
Offer a terse response. 1.1. What is the ratio of the Number of refugees in Benin in 2005 to that in 2008?
Your response must be concise. 4.37. What is the ratio of the Number of refugees of Indonesia in 2005 to that in 2008?
Make the answer very short. 0.24. What is the ratio of the Number of refugees of Moldova in 2005 to that in 2008?
Offer a terse response. 0.57. What is the ratio of the Number of refugees of East Asia (all income levels) in 2005 to that in 2009?
Provide a succinct answer. 1.05. What is the ratio of the Number of refugees in Benin in 2005 to that in 2009?
Your answer should be very brief. 4.2. What is the ratio of the Number of refugees of Indonesia in 2005 to that in 2009?
Provide a succinct answer. 0.11. What is the ratio of the Number of refugees of Moldova in 2005 to that in 2009?
Ensure brevity in your answer.  0.6. What is the ratio of the Number of refugees of East Asia (all income levels) in 2005 to that in 2010?
Your answer should be compact. 1.04. What is the ratio of the Number of refugees in Benin in 2005 to that in 2010?
Provide a succinct answer. 4.24. What is the ratio of the Number of refugees in Indonesia in 2005 to that in 2010?
Give a very brief answer. 0.11. What is the ratio of the Number of refugees of Moldova in 2005 to that in 2010?
Offer a terse response. 0.57. What is the ratio of the Number of refugees in East Asia (all income levels) in 2005 to that in 2011?
Your answer should be compact. 1.04. What is the ratio of the Number of refugees in Benin in 2005 to that in 2011?
Make the answer very short. 4.2. What is the ratio of the Number of refugees in Indonesia in 2005 to that in 2011?
Ensure brevity in your answer.  0.09. What is the ratio of the Number of refugees of Moldova in 2005 to that in 2011?
Give a very brief answer. 0.58. What is the ratio of the Number of refugees in East Asia (all income levels) in 2006 to that in 2007?
Your response must be concise. 1.13. What is the ratio of the Number of refugees of Benin in 2006 to that in 2007?
Ensure brevity in your answer.  1.42. What is the ratio of the Number of refugees in Indonesia in 2006 to that in 2007?
Ensure brevity in your answer.  0.96. What is the ratio of the Number of refugees in Moldova in 2006 to that in 2007?
Give a very brief answer. 1.07. What is the ratio of the Number of refugees of East Asia (all income levels) in 2006 to that in 2008?
Offer a very short reply. 1.15. What is the ratio of the Number of refugees of Benin in 2006 to that in 2008?
Your answer should be very brief. 1.56. What is the ratio of the Number of refugees in Indonesia in 2006 to that in 2008?
Keep it short and to the point. 0.82. What is the ratio of the Number of refugees in Moldova in 2006 to that in 2008?
Ensure brevity in your answer.  1.09. What is the ratio of the Number of refugees in East Asia (all income levels) in 2006 to that in 2009?
Your answer should be very brief. 1.09. What is the ratio of the Number of refugees of Benin in 2006 to that in 2009?
Offer a terse response. 1.5. What is the ratio of the Number of refugees in Indonesia in 2006 to that in 2009?
Provide a succinct answer. 0.38. What is the ratio of the Number of refugees of Moldova in 2006 to that in 2009?
Your response must be concise. 1.14. What is the ratio of the Number of refugees of East Asia (all income levels) in 2006 to that in 2010?
Make the answer very short. 1.08. What is the ratio of the Number of refugees in Benin in 2006 to that in 2010?
Provide a short and direct response. 1.51. What is the ratio of the Number of refugees in Indonesia in 2006 to that in 2010?
Provide a short and direct response. 0.37. What is the ratio of the Number of refugees in Moldova in 2006 to that in 2010?
Offer a very short reply. 1.09. What is the ratio of the Number of refugees of East Asia (all income levels) in 2006 to that in 2011?
Offer a very short reply. 1.09. What is the ratio of the Number of refugees of Benin in 2006 to that in 2011?
Offer a very short reply. 1.5. What is the ratio of the Number of refugees of Indonesia in 2006 to that in 2011?
Give a very brief answer. 0.3. What is the ratio of the Number of refugees in Moldova in 2006 to that in 2011?
Make the answer very short. 1.1. What is the ratio of the Number of refugees of East Asia (all income levels) in 2007 to that in 2008?
Your response must be concise. 1.02. What is the ratio of the Number of refugees in Benin in 2007 to that in 2008?
Make the answer very short. 1.1. What is the ratio of the Number of refugees of Indonesia in 2007 to that in 2008?
Your answer should be compact. 0.85. What is the ratio of the Number of refugees in Moldova in 2007 to that in 2008?
Make the answer very short. 1.02. What is the ratio of the Number of refugees of East Asia (all income levels) in 2007 to that in 2009?
Ensure brevity in your answer.  0.97. What is the ratio of the Number of refugees of Benin in 2007 to that in 2009?
Offer a terse response. 1.06. What is the ratio of the Number of refugees of Indonesia in 2007 to that in 2009?
Offer a terse response. 0.39. What is the ratio of the Number of refugees of Moldova in 2007 to that in 2009?
Your answer should be compact. 1.07. What is the ratio of the Number of refugees in East Asia (all income levels) in 2007 to that in 2010?
Ensure brevity in your answer.  0.96. What is the ratio of the Number of refugees in Benin in 2007 to that in 2010?
Provide a short and direct response. 1.07. What is the ratio of the Number of refugees in Indonesia in 2007 to that in 2010?
Offer a very short reply. 0.39. What is the ratio of the Number of refugees of Moldova in 2007 to that in 2010?
Your answer should be very brief. 1.02. What is the ratio of the Number of refugees in East Asia (all income levels) in 2007 to that in 2011?
Provide a succinct answer. 0.97. What is the ratio of the Number of refugees in Benin in 2007 to that in 2011?
Make the answer very short. 1.06. What is the ratio of the Number of refugees of Indonesia in 2007 to that in 2011?
Make the answer very short. 0.31. What is the ratio of the Number of refugees of Moldova in 2007 to that in 2011?
Keep it short and to the point. 1.03. What is the ratio of the Number of refugees of East Asia (all income levels) in 2008 to that in 2009?
Make the answer very short. 0.95. What is the ratio of the Number of refugees of Benin in 2008 to that in 2009?
Provide a succinct answer. 0.96. What is the ratio of the Number of refugees in Indonesia in 2008 to that in 2009?
Your answer should be very brief. 0.46. What is the ratio of the Number of refugees of Moldova in 2008 to that in 2009?
Provide a succinct answer. 1.05. What is the ratio of the Number of refugees in East Asia (all income levels) in 2008 to that in 2010?
Keep it short and to the point. 0.94. What is the ratio of the Number of refugees of Benin in 2008 to that in 2010?
Offer a very short reply. 0.97. What is the ratio of the Number of refugees of Indonesia in 2008 to that in 2010?
Provide a succinct answer. 0.46. What is the ratio of the Number of refugees of Moldova in 2008 to that in 2010?
Your answer should be compact. 1. What is the ratio of the Number of refugees in East Asia (all income levels) in 2008 to that in 2011?
Your response must be concise. 0.95. What is the ratio of the Number of refugees of Benin in 2008 to that in 2011?
Your answer should be compact. 0.96. What is the ratio of the Number of refugees of Indonesia in 2008 to that in 2011?
Offer a very short reply. 0.37. What is the ratio of the Number of refugees of Moldova in 2008 to that in 2011?
Give a very brief answer. 1.01. What is the ratio of the Number of refugees of East Asia (all income levels) in 2009 to that in 2010?
Your answer should be very brief. 0.99. What is the ratio of the Number of refugees of Benin in 2009 to that in 2010?
Provide a succinct answer. 1.01. What is the ratio of the Number of refugees of Moldova in 2009 to that in 2010?
Your answer should be compact. 0.95. What is the ratio of the Number of refugees of East Asia (all income levels) in 2009 to that in 2011?
Your answer should be compact. 0.99. What is the ratio of the Number of refugees in Benin in 2009 to that in 2011?
Offer a very short reply. 1. What is the ratio of the Number of refugees in Indonesia in 2009 to that in 2011?
Your answer should be compact. 0.79. What is the ratio of the Number of refugees in Moldova in 2009 to that in 2011?
Your answer should be compact. 0.97. What is the ratio of the Number of refugees in East Asia (all income levels) in 2010 to that in 2011?
Provide a short and direct response. 1. What is the ratio of the Number of refugees in Indonesia in 2010 to that in 2011?
Your answer should be very brief. 0.81. What is the ratio of the Number of refugees in Moldova in 2010 to that in 2011?
Give a very brief answer. 1.01. What is the difference between the highest and the second highest Number of refugees in East Asia (all income levels)?
Provide a short and direct response. 2.34e+04. What is the difference between the highest and the second highest Number of refugees in Benin?
Your answer should be compact. 1.95e+04. What is the difference between the highest and the second highest Number of refugees of Indonesia?
Provide a short and direct response. 195. What is the difference between the highest and the lowest Number of refugees of East Asia (all income levels)?
Provide a short and direct response. 7.26e+04. What is the difference between the highest and the lowest Number of refugees in Benin?
Your answer should be very brief. 2.55e+04. What is the difference between the highest and the lowest Number of refugees in Indonesia?
Your response must be concise. 917. What is the difference between the highest and the lowest Number of refugees in Moldova?
Your answer should be very brief. 104. 